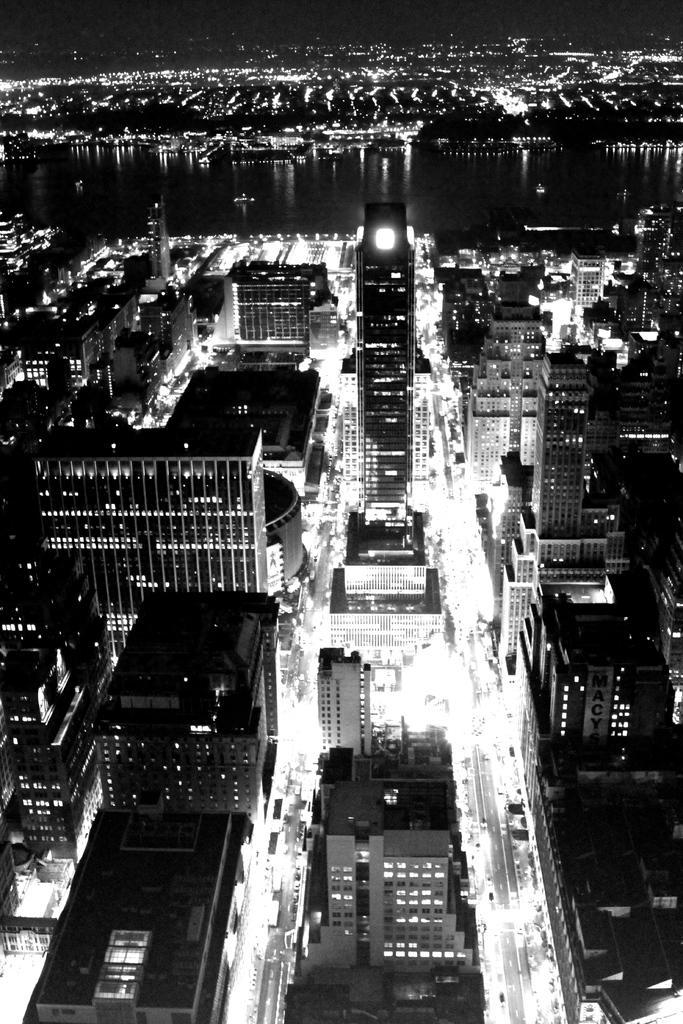How would you summarize this image in a sentence or two? In this picture we can see many buildings and lights. We can see some water. 